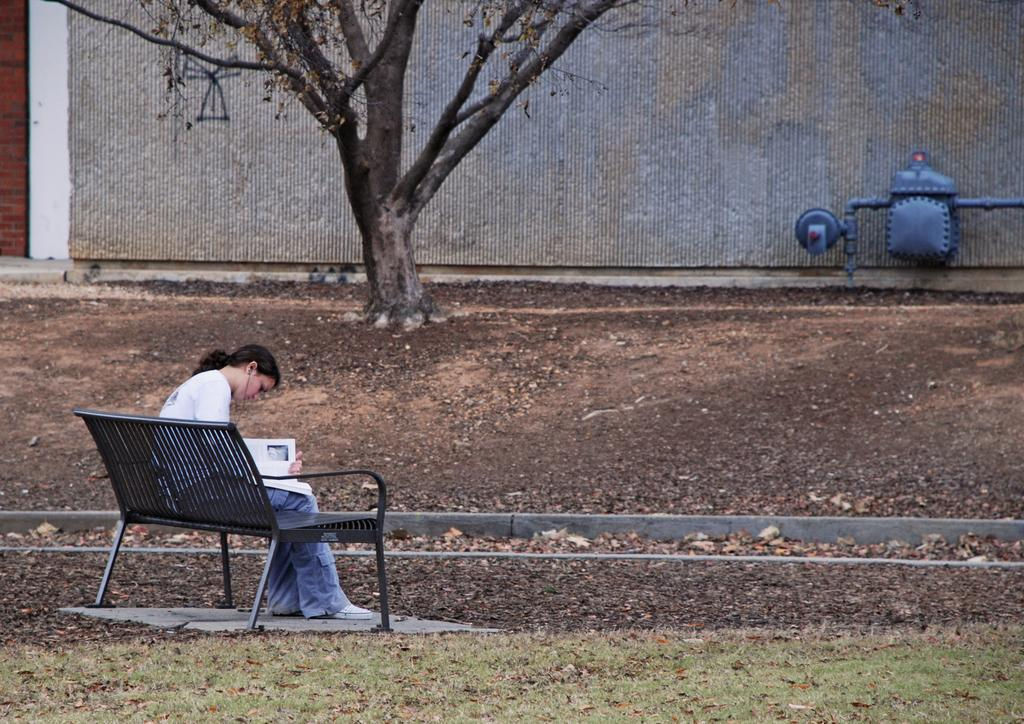What is the woman in the image doing? The woman is sitting on a bench in the image. What can be seen in the background of the image? There is a wall in the background of the image. What is located in the top right of the image? There is a pipe machine in the top right of the image. Can you tell me how many airports are visible in the image? There are no airports present in the image. What type of exchange is taking place between the woman and the pipe machine? There is no exchange taking place between the woman and the pipe machine in the image. 